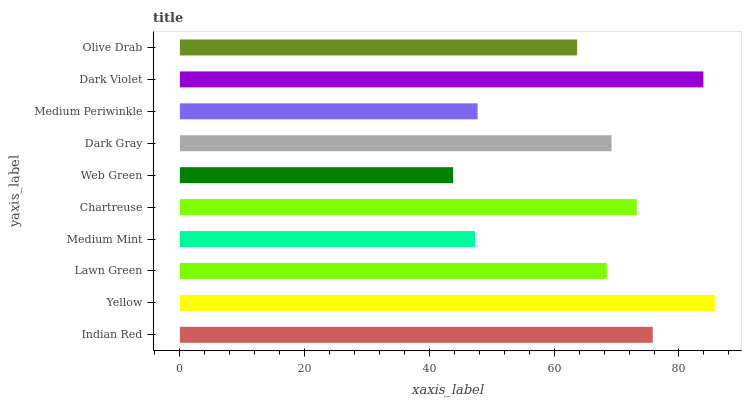Is Web Green the minimum?
Answer yes or no. Yes. Is Yellow the maximum?
Answer yes or no. Yes. Is Lawn Green the minimum?
Answer yes or no. No. Is Lawn Green the maximum?
Answer yes or no. No. Is Yellow greater than Lawn Green?
Answer yes or no. Yes. Is Lawn Green less than Yellow?
Answer yes or no. Yes. Is Lawn Green greater than Yellow?
Answer yes or no. No. Is Yellow less than Lawn Green?
Answer yes or no. No. Is Dark Gray the high median?
Answer yes or no. Yes. Is Lawn Green the low median?
Answer yes or no. Yes. Is Yellow the high median?
Answer yes or no. No. Is Chartreuse the low median?
Answer yes or no. No. 